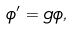<formula> <loc_0><loc_0><loc_500><loc_500>\phi ^ { \prime } = g \phi ,</formula> 